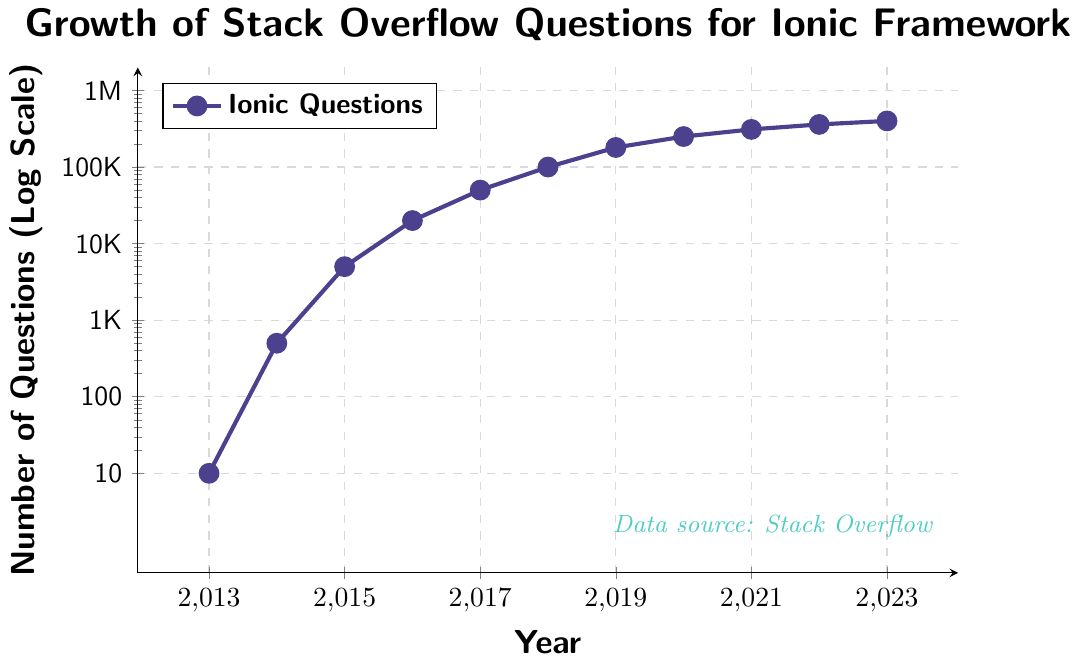How many times did the number of questions increase from 2013 to 2014? From 2013 to 2014, the number of questions increased from 10 to 500. The increase factor is 500 / 10 = 50.
Answer: 50 Between which two consecutive years did the number of questions see the largest increase? To determine this, look at the differences between consecutive years: 2014 (490), 2015 (4500), 2016 (15000), 2017 (30000), 2018 (50000), 2019 (80000), 2020 (70000), 2021 (60000), 2022 (50000), 2023 (40000). The largest increase is between 2018 and 2019 with an increase of 80000 questions.
Answer: 2018-2019 What is the total number of questions by 2017? Sum the yearly cumulative total up to 2017: 10 (2013) + 500 (2014) + 5000 (2015) + 20000 (2016) + 50000 (2017) = 75510 questions.
Answer: 75510 Which year had the steepest growth rate in terms of question counts? To find the steepest growth rate, compare the relative increase each year. The highest relative increase is seen from 2013 (10 questions) to 2014 (500 questions), which is a 50-fold increase.
Answer: 2014 During which years did the number of questions double or more compared to the previous year? Compare each year to the previous one to check if it doubled (or more): 2014 compared to 2013 (10 to 500, yes), 2015 compared to 2014 (500 to 5000, yes), 2016 compared to 2015 (5000 to 20000, yes). The rest did not meet this criterion.
Answer: 2014, 2015, 2016 What visual elements are used to represent the data in the figure? The chart uses a line plot with connected dots, a log scale for the y-axis, grid lines, and specific colors for the data points and trend line.
Answer: Line plot, dots, log scale, grid lines What is the average yearly question count increase from 2013 to 2023? Calculate the total increase from 2013 to 2023: (400000 - 10) = 399990. Then, divide by the number of years (2023-2013 = 10): 399990 / 10 ≈ 39999.
Answer: 39999 